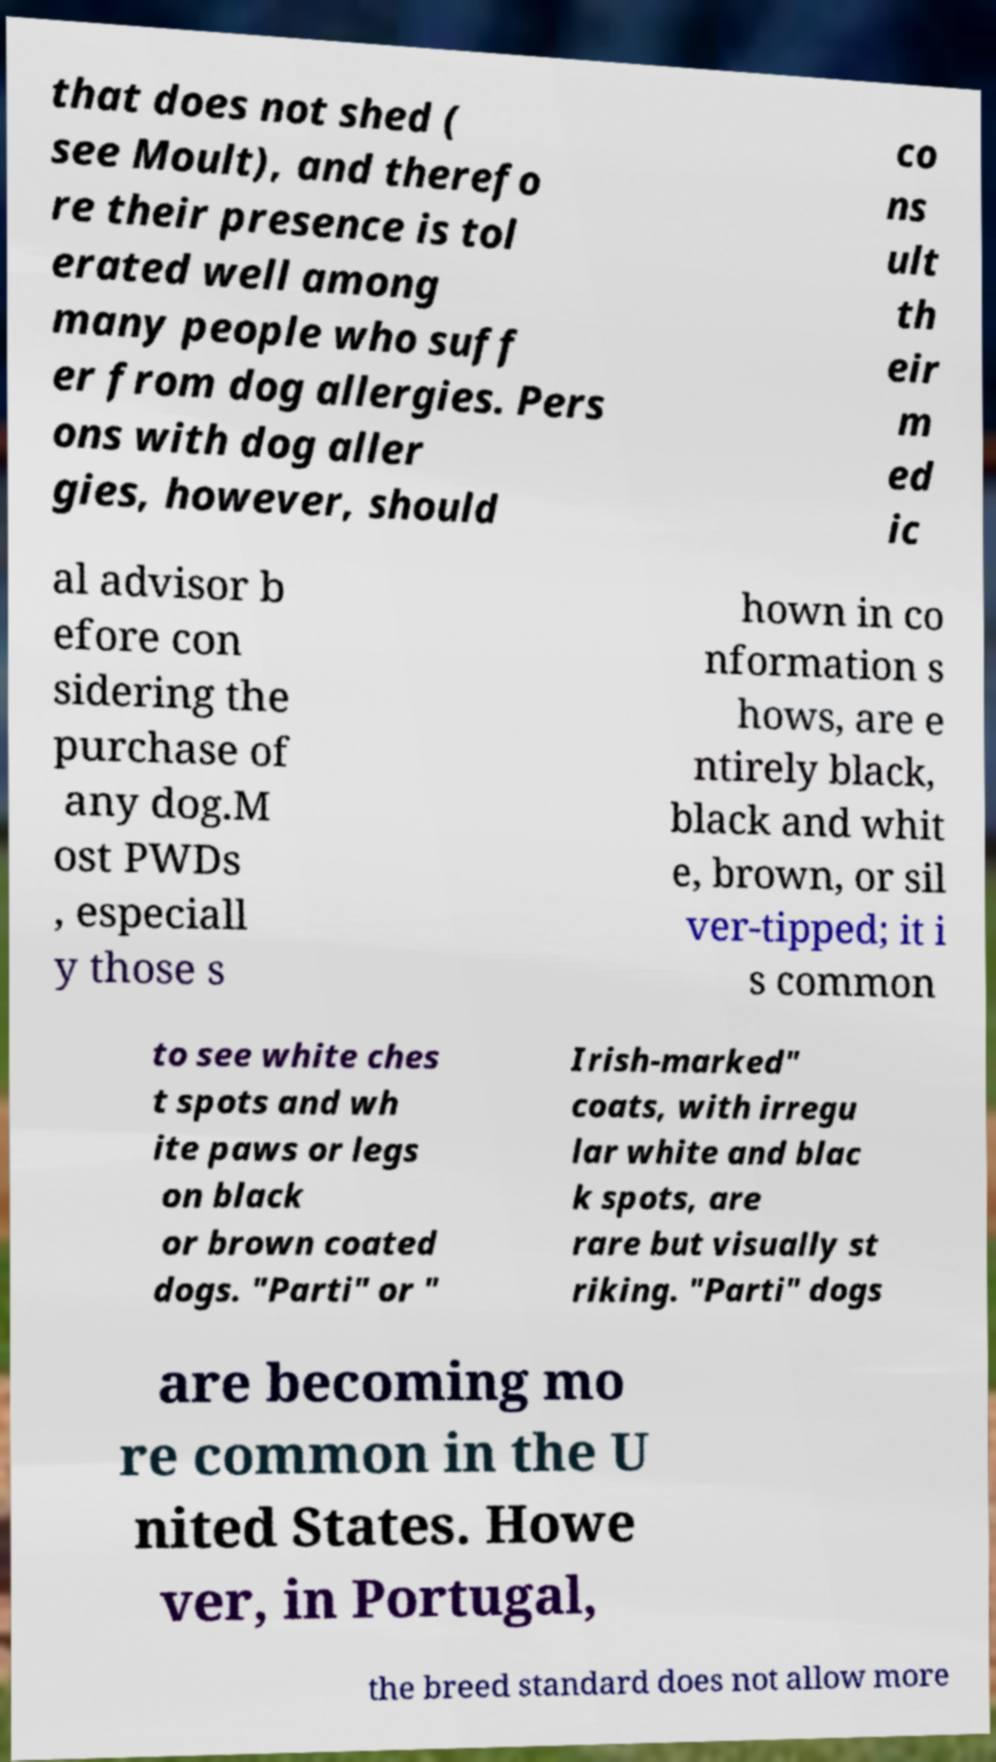Please identify and transcribe the text found in this image. that does not shed ( see Moult), and therefo re their presence is tol erated well among many people who suff er from dog allergies. Pers ons with dog aller gies, however, should co ns ult th eir m ed ic al advisor b efore con sidering the purchase of any dog.M ost PWDs , especiall y those s hown in co nformation s hows, are e ntirely black, black and whit e, brown, or sil ver-tipped; it i s common to see white ches t spots and wh ite paws or legs on black or brown coated dogs. "Parti" or " Irish-marked" coats, with irregu lar white and blac k spots, are rare but visually st riking. "Parti" dogs are becoming mo re common in the U nited States. Howe ver, in Portugal, the breed standard does not allow more 